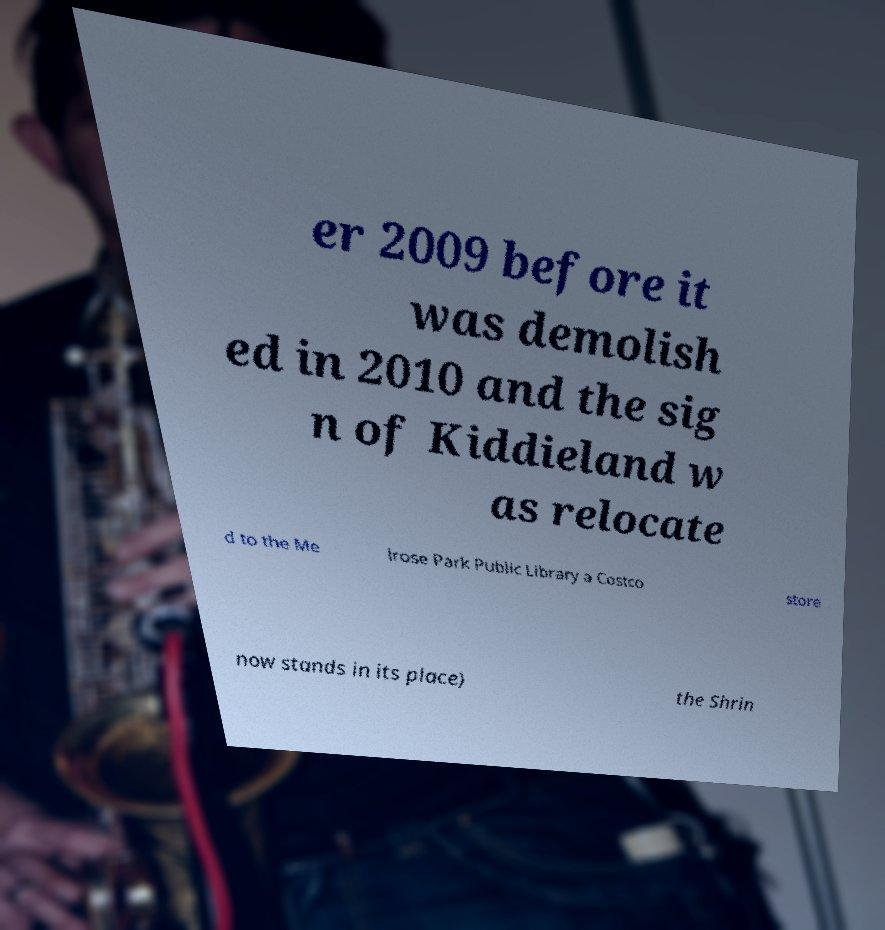What messages or text are displayed in this image? I need them in a readable, typed format. er 2009 before it was demolish ed in 2010 and the sig n of Kiddieland w as relocate d to the Me lrose Park Public Library a Costco store now stands in its place) the Shrin 